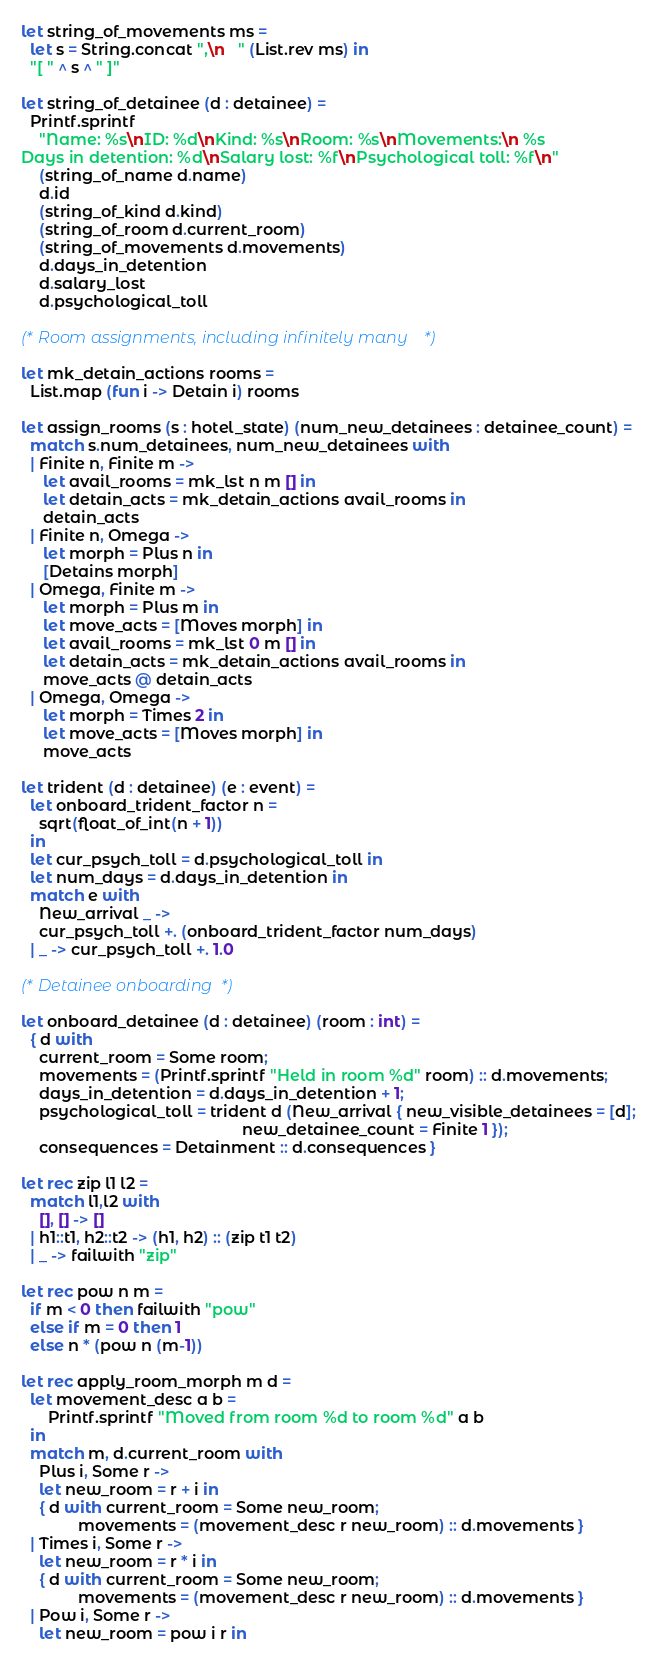<code> <loc_0><loc_0><loc_500><loc_500><_OCaml_>
let string_of_movements ms =
  let s = String.concat ",\n   " (List.rev ms) in
  "[ " ^ s ^ " ]"

let string_of_detainee (d : detainee) =
  Printf.sprintf
    "Name: %s\nID: %d\nKind: %s\nRoom: %s\nMovements:\n %s
Days in detention: %d\nSalary lost: %f\nPsychological toll: %f\n"
    (string_of_name d.name)
    d.id
    (string_of_kind d.kind)
    (string_of_room d.current_room)
    (string_of_movements d.movements)
    d.days_in_detention
    d.salary_lost
    d.psychological_toll

(* Room assignments, including infinitely many *)

let mk_detain_actions rooms =
  List.map (fun i -> Detain i) rooms

let assign_rooms (s : hotel_state) (num_new_detainees : detainee_count) =
  match s.num_detainees, num_new_detainees with
  | Finite n, Finite m ->
     let avail_rooms = mk_lst n m [] in
     let detain_acts = mk_detain_actions avail_rooms in
     detain_acts
  | Finite n, Omega ->
     let morph = Plus n in
     [Detains morph]
  | Omega, Finite m ->
     let morph = Plus m in
     let move_acts = [Moves morph] in
     let avail_rooms = mk_lst 0 m [] in
     let detain_acts = mk_detain_actions avail_rooms in
     move_acts @ detain_acts
  | Omega, Omega ->
     let morph = Times 2 in
     let move_acts = [Moves morph] in
     move_acts

let trident (d : detainee) (e : event) =
  let onboard_trident_factor n =
    sqrt(float_of_int(n + 1))
  in
  let cur_psych_toll = d.psychological_toll in
  let num_days = d.days_in_detention in
  match e with
    New_arrival _ ->
    cur_psych_toll +. (onboard_trident_factor num_days)
  | _ -> cur_psych_toll +. 1.0

(* Detainee onboarding *)

let onboard_detainee (d : detainee) (room : int) =
  { d with
    current_room = Some room;
    movements = (Printf.sprintf "Held in room %d" room) :: d.movements;
    days_in_detention = d.days_in_detention + 1;
    psychological_toll = trident d (New_arrival { new_visible_detainees = [d];
                                                  new_detainee_count = Finite 1 });
    consequences = Detainment :: d.consequences }

let rec zip l1 l2 =
  match l1,l2 with
    [], [] -> []
  | h1::t1, h2::t2 -> (h1, h2) :: (zip t1 t2)
  | _ -> failwith "zip"

let rec pow n m =
  if m < 0 then failwith "pow"
  else if m = 0 then 1
  else n * (pow n (m-1))

let rec apply_room_morph m d =
  let movement_desc a b =
      Printf.sprintf "Moved from room %d to room %d" a b
  in
  match m, d.current_room with
    Plus i, Some r ->
    let new_room = r + i in
    { d with current_room = Some new_room;
             movements = (movement_desc r new_room) :: d.movements }
  | Times i, Some r ->
    let new_room = r * i in
    { d with current_room = Some new_room;
             movements = (movement_desc r new_room) :: d.movements }
  | Pow i, Some r ->
    let new_room = pow i r in</code> 